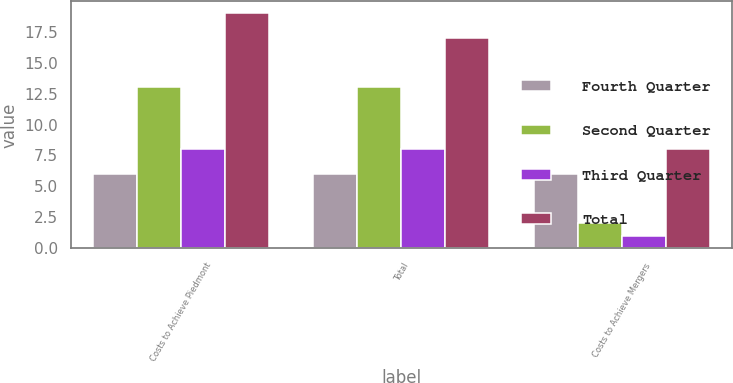Convert chart to OTSL. <chart><loc_0><loc_0><loc_500><loc_500><stacked_bar_chart><ecel><fcel>Costs to Achieve Piedmont<fcel>Total<fcel>Costs to Achieve Mergers<nl><fcel>Fourth Quarter<fcel>6<fcel>6<fcel>6<nl><fcel>Second Quarter<fcel>13<fcel>13<fcel>2<nl><fcel>Third Quarter<fcel>8<fcel>8<fcel>1<nl><fcel>Total<fcel>19<fcel>17<fcel>8<nl></chart> 